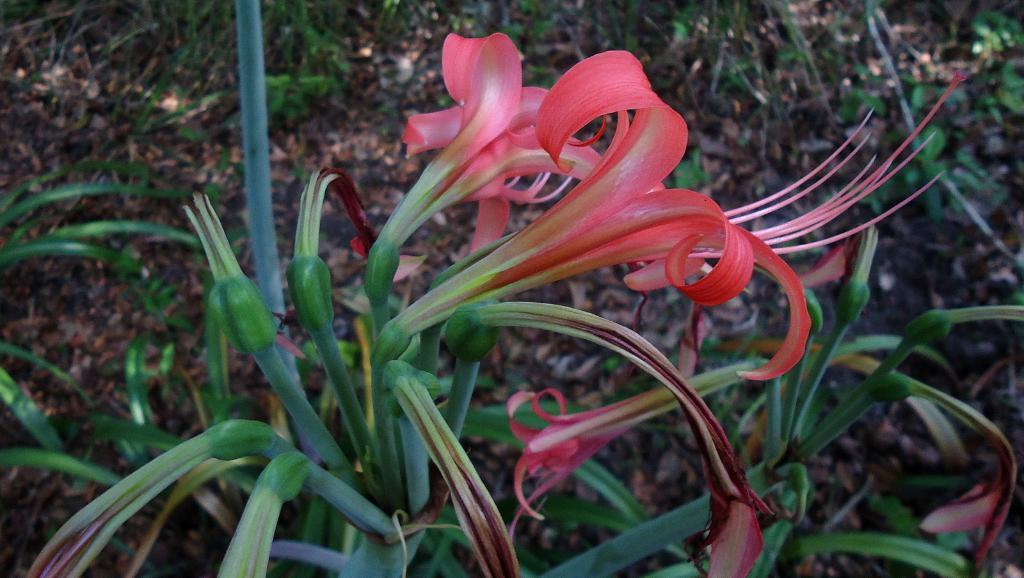What type of plants can be seen in the image? There are plants with flowers and plants with buds in the image. What is the condition of the leaves on the plants? There are dried leaves behind the plants. What type of vegetation is present behind the plants? There is grass behind the plants. What type of wine is being served in the image? There is no wine present in the image; it features plants with flowers and buds, dried leaves, and grass. How many dogs are visible in the image? There are no dogs present in the image. 